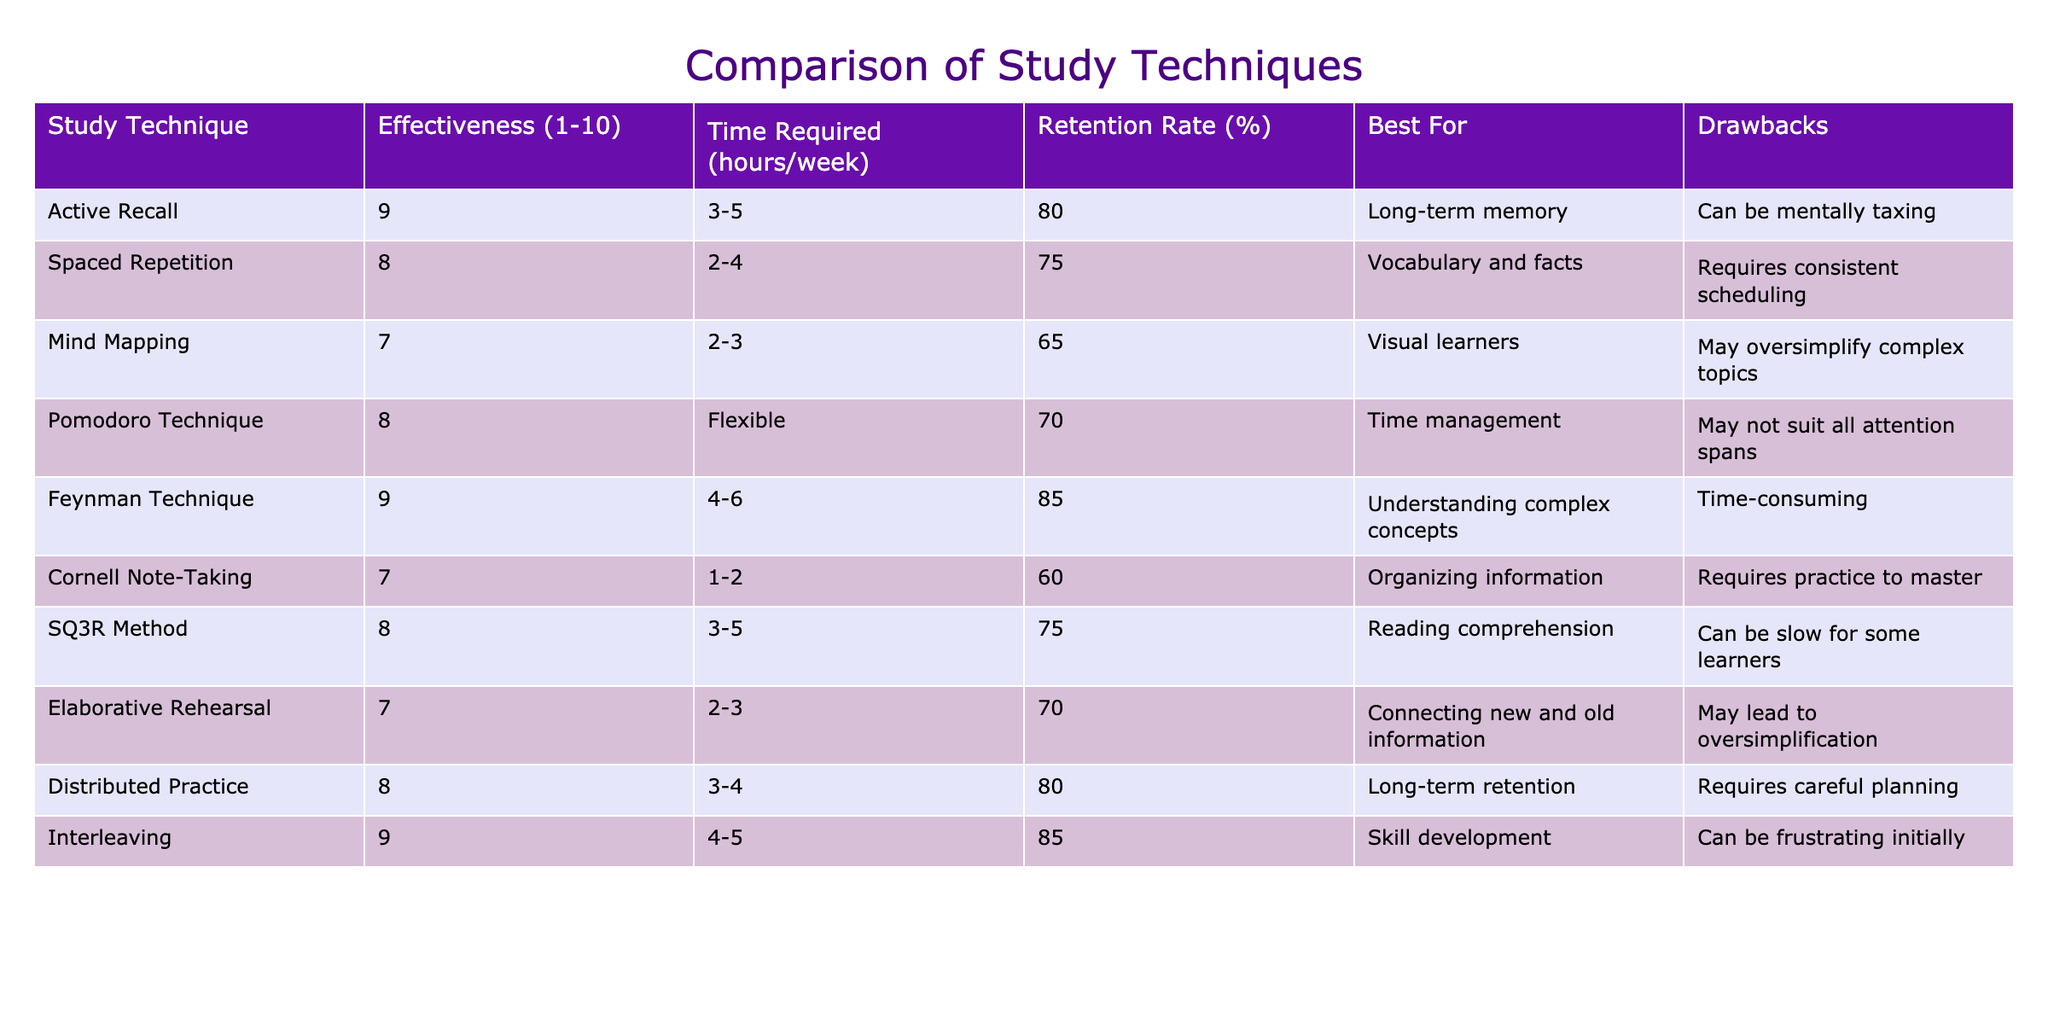What is the effectiveness rating of Active Recall? The table shows the effectiveness of Active Recall listed under the Effectiveness column, which is 9.
Answer: 9 Which study technique has the highest retention rate? By reviewing the Retention Rate column, Interleaving and Feynman Technique both have the highest retention rate at 85%, but we are looking for which one is listed first, and that is the Feynman Technique.
Answer: Feynman Technique How many hours per week does the Cornell Note-Taking technique require at minimum? The Time Required column lists Cornell Note-Taking needing 1-2 hours per week, so the minimum is 1 hour.
Answer: 1 hour Is the Pomodoro Technique suitable for everyone? The table mentions a drawback for the Pomodoro Technique stating, "May not suit all attention spans," implying it is not suitable for everyone.
Answer: No What is the average effectiveness rating of the techniques that are best for long-term retention? The techniques that are best for long-term retention according to the table are Active Recall, Distributed Practice, and Feynman Technique, with effectiveness ratings of 9, 8, and 9 respectively. To find the average, sum these values (9 + 8 + 9 = 26) and divide by the number of techniques (26 / 3 ≈ 8.67).
Answer: 8.67 